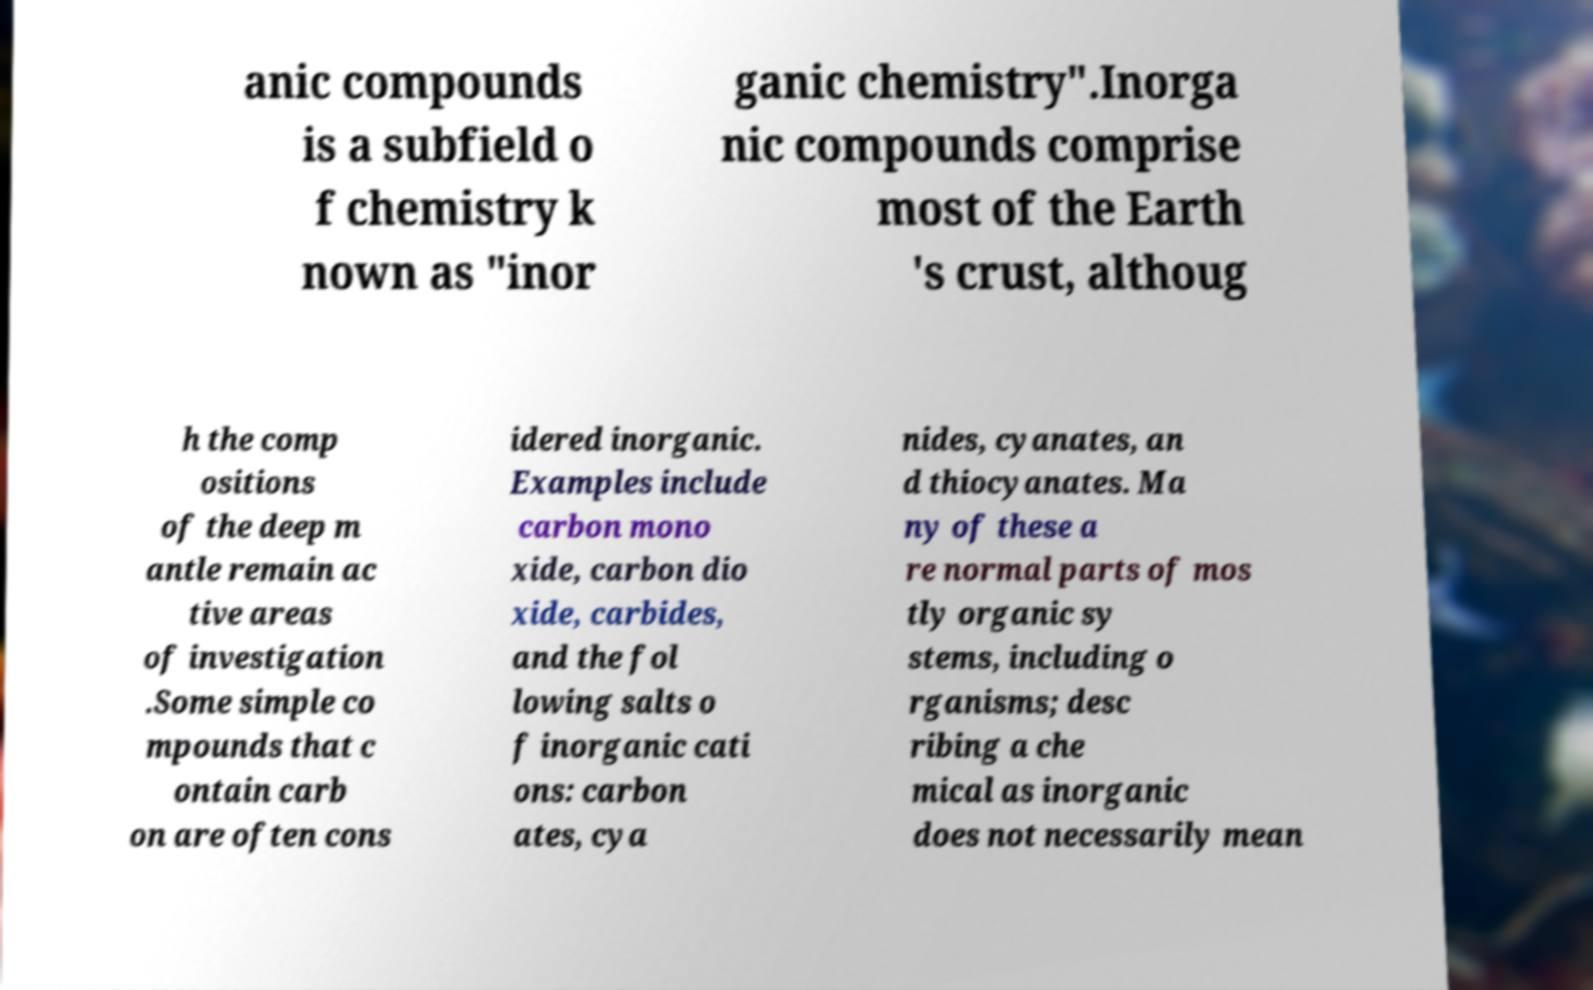Could you extract and type out the text from this image? anic compounds is a subfield o f chemistry k nown as "inor ganic chemistry".Inorga nic compounds comprise most of the Earth 's crust, althoug h the comp ositions of the deep m antle remain ac tive areas of investigation .Some simple co mpounds that c ontain carb on are often cons idered inorganic. Examples include carbon mono xide, carbon dio xide, carbides, and the fol lowing salts o f inorganic cati ons: carbon ates, cya nides, cyanates, an d thiocyanates. Ma ny of these a re normal parts of mos tly organic sy stems, including o rganisms; desc ribing a che mical as inorganic does not necessarily mean 